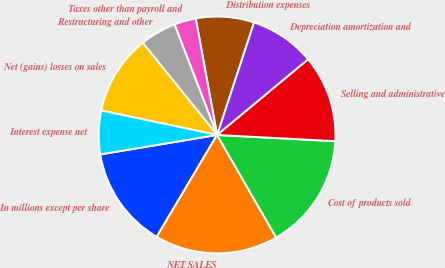<chart> <loc_0><loc_0><loc_500><loc_500><pie_chart><fcel>In millions except per share<fcel>NET SALES<fcel>Cost of products sold<fcel>Selling and administrative<fcel>Depreciation amortization and<fcel>Distribution expenses<fcel>Taxes other than payroll and<fcel>Restructuring and other<fcel>Net (gains) losses on sales<fcel>Interest expense net<nl><fcel>13.86%<fcel>16.83%<fcel>15.84%<fcel>11.88%<fcel>8.91%<fcel>7.92%<fcel>2.97%<fcel>4.95%<fcel>10.89%<fcel>5.94%<nl></chart> 